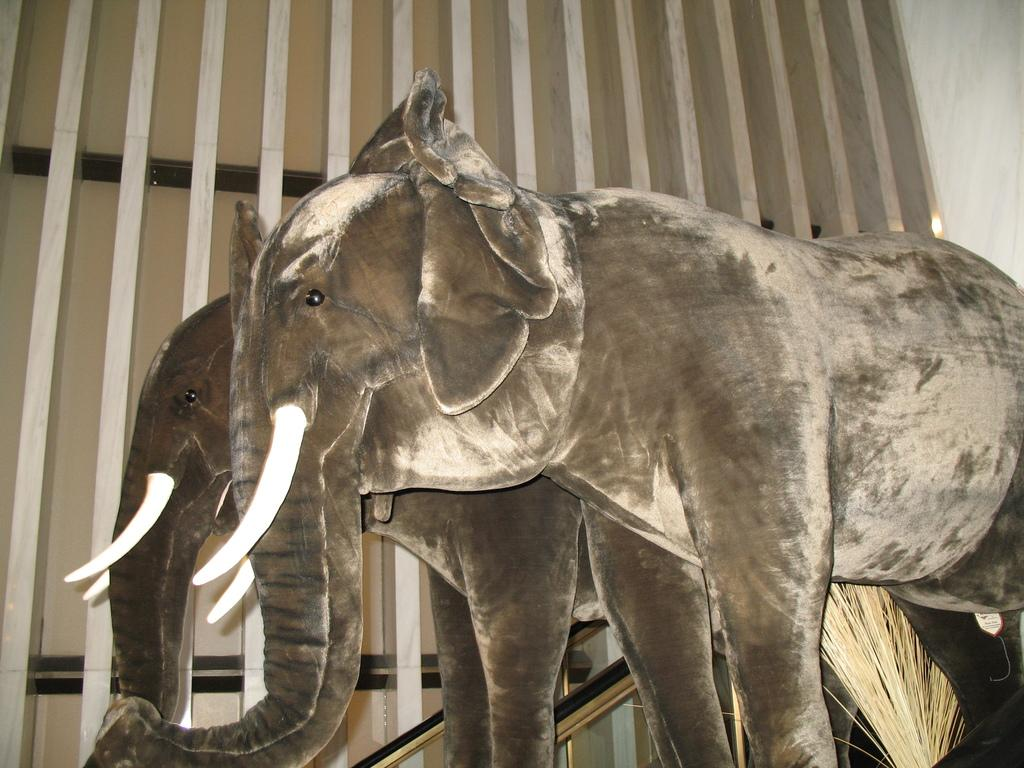What is depicted on the cardboard sheets in the image? There are cardboard sheets of elephants in the image. What can be seen in the background of the image? There is a wall visible in the image. How many geese are flying over the wall in the image? There are no geese visible in the image; it only features cardboard sheets of elephants and a wall. What type of line is connecting the elephants on the cardboard sheets? There is no line connecting the elephants on the cardboard sheets in the image. 